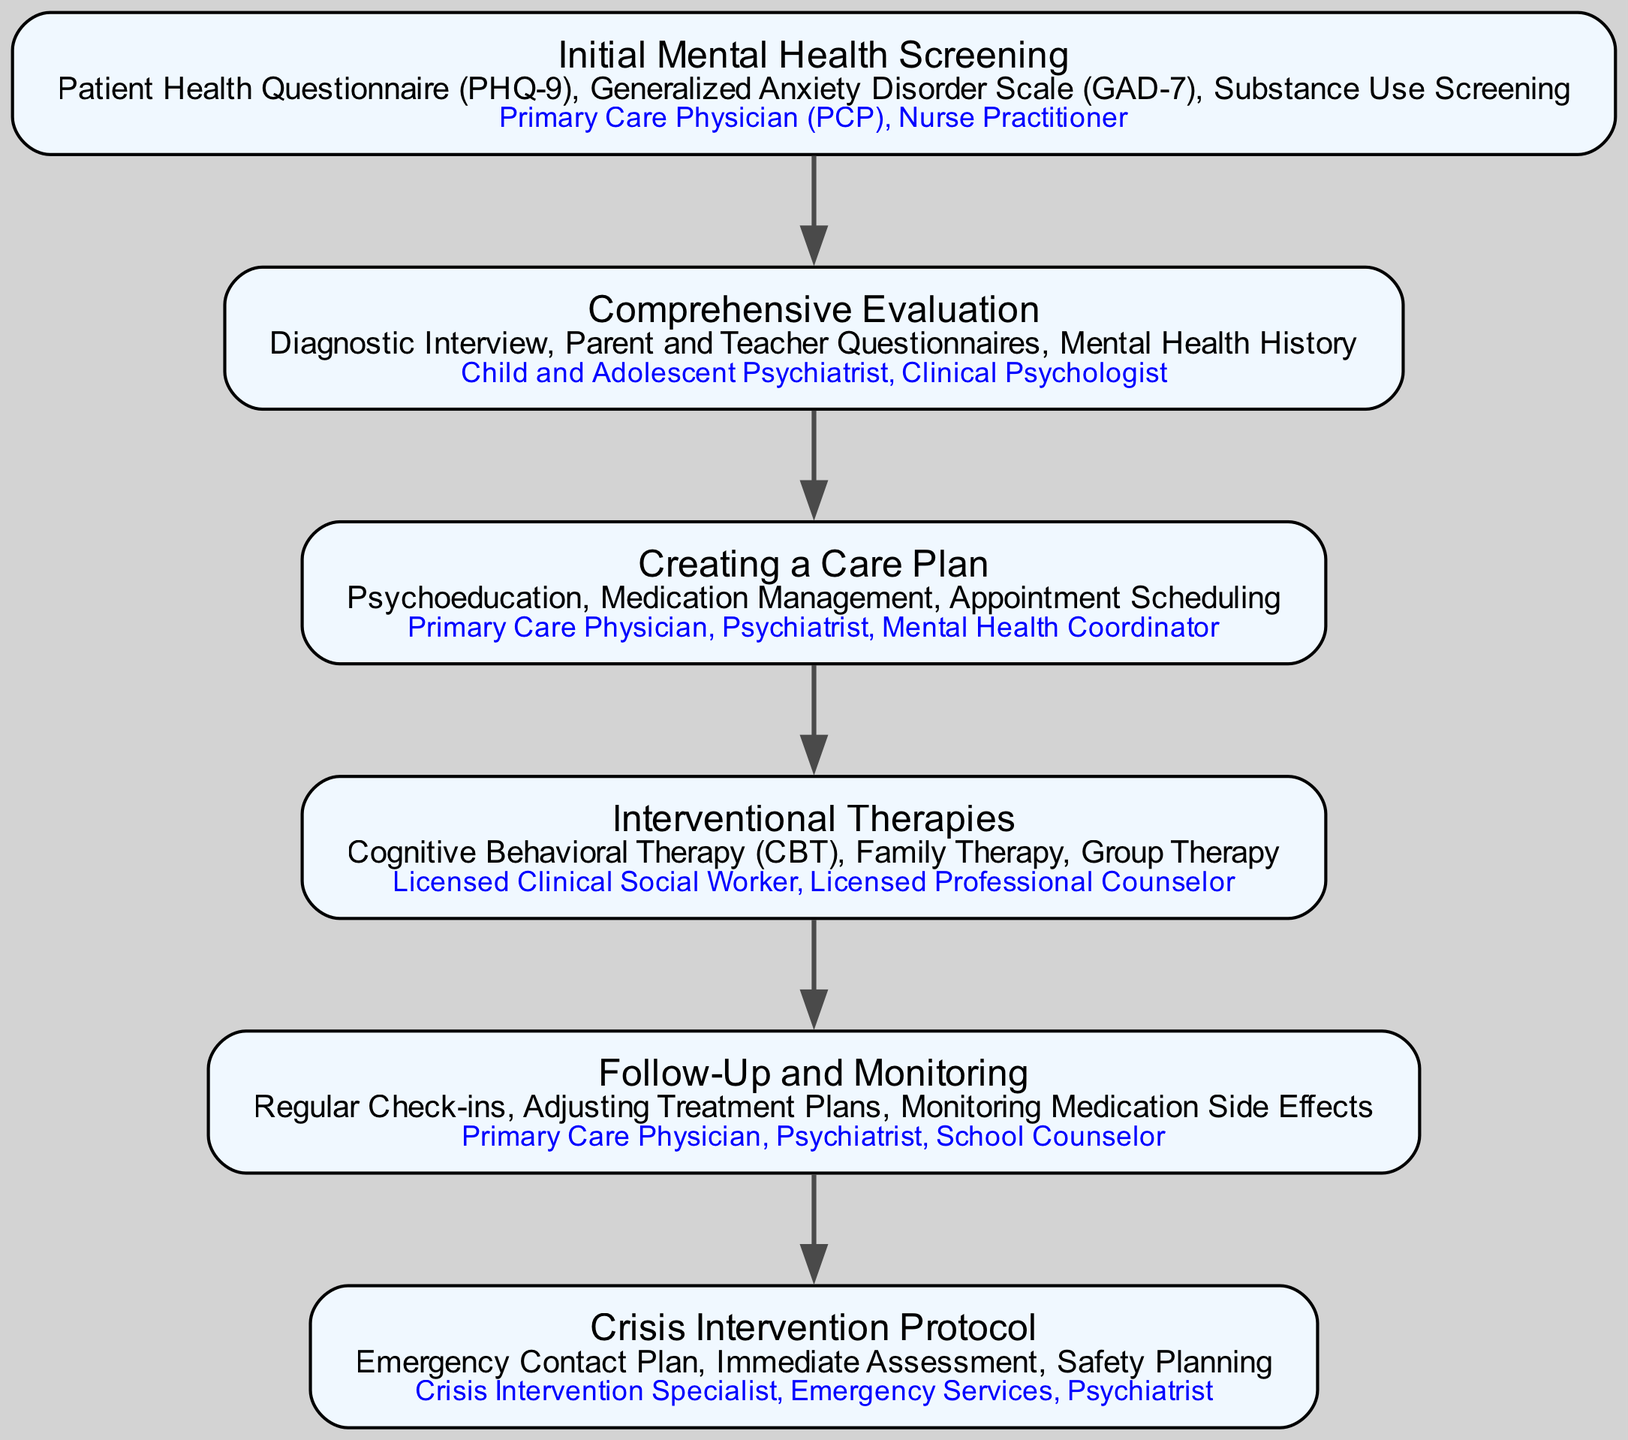What is the first step in the clinical pathway? The diagram indicates that the first step in the clinical pathway is "Initial Mental Health Screening".
Answer: Initial Mental Health Screening How many components are in the Crisis Intervention Protocol? By examining the "Crisis Management" section, it can be seen that there are three components listed: Emergency Contact Plan, Immediate Assessment, and Safety Planning.
Answer: 3 Who provides the Comprehensive Evaluation? The "Secondary Assessment" node shows that the Comprehensive Evaluation is provided by the Child and Adolescent Psychiatrist and Clinical Psychologist.
Answer: Child and Adolescent Psychiatrist, Clinical Psychologist What follows the Creating a Care Plan step? The flow of the diagram shows that the "Interventional Therapies" step follows after "Creating a Care Plan".
Answer: Interventional Therapies What is the main purpose of the Follow-Up and Monitoring step? The components of the "Ongoing Monitoring" step describe the purposes, which include Regular Check-ins, Adjusting Treatment Plans, and Monitoring Medication Side Effects.
Answer: Regular Check-ins, Adjusting Treatment Plans, Monitoring Medication Side Effects How many providers are involved in the Initial Assessment? The "Initial Assessment" step highlights that the providers involved are the Primary Care Physician and Nurse Practitioner, amounting to two providers.
Answer: 2 Which component is part of the Creating a Care Plan? Looking at the "Collaborative Care Plan" step, one of the components listed is "Psychoeducation".
Answer: Psychoeducation What is the overall focus of the clinical pathway depicted in the diagram? The pathway illustrates an integrated approach to managing adolescent mental health within primary care settings, showcasing various assessment, intervention, and monitoring steps.
Answer: Integrated approach to adolescent mental health What is the last step in the clinical pathway? The diagram shows that the last step in the clinical pathway is "Crisis Intervention Protocol".
Answer: Crisis Intervention Protocol Which two components are shared between Interventional Therapies and Creating a Care Plan? Analyzing the components shows that both sections include therapy options, but specifically, they share "Cognitive Behavioral Therapy" as a common component.
Answer: Cognitive Behavioral Therapy 